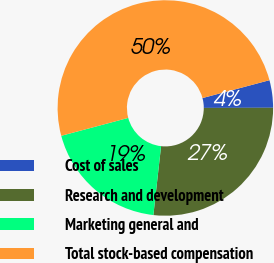<chart> <loc_0><loc_0><loc_500><loc_500><pie_chart><fcel>Cost of sales<fcel>Research and development<fcel>Marketing general and<fcel>Total stock-based compensation<nl><fcel>4.12%<fcel>26.8%<fcel>19.07%<fcel>50.0%<nl></chart> 